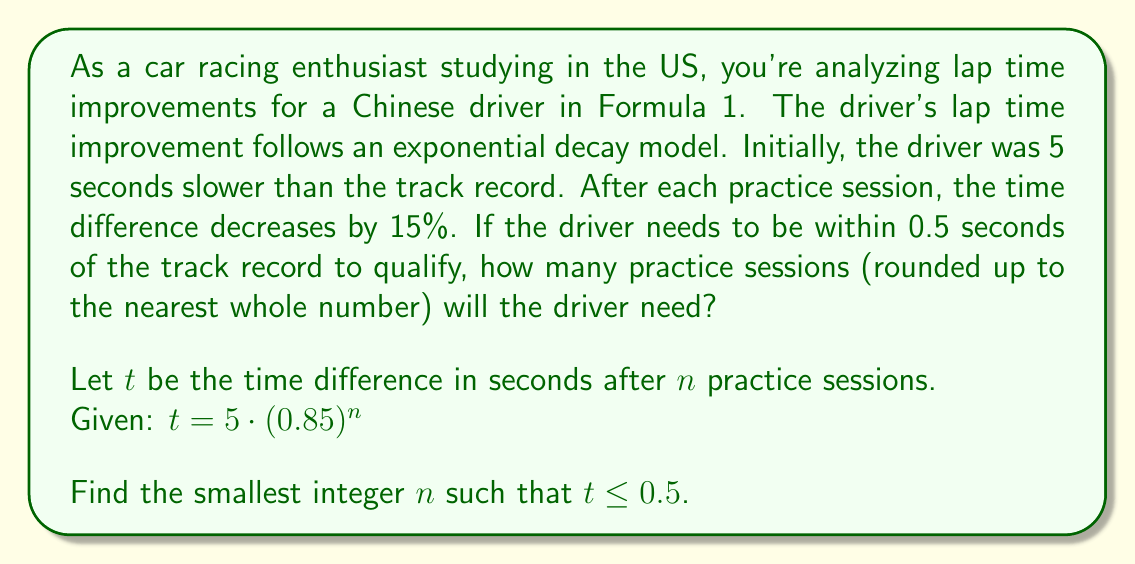What is the answer to this math problem? Let's approach this step-by-step:

1) We start with the exponential decay formula:
   $t = 5 \cdot (0.85)^n$

2) We want to find $n$ when $t \leq 0.5$. So, let's set up the inequality:
   $5 \cdot (0.85)^n \leq 0.5$

3) Divide both sides by 5:
   $(0.85)^n \leq 0.1$

4) To solve for $n$, we need to take the logarithm of both sides. Since we're dealing with a base less than 1, the inequality sign will flip when we take the log:
   $\log_{0.85}(0.85)^n \geq \log_{0.85}(0.1)$

5) Using the logarithm property $\log_a(a^x) = x$, we get:
   $n \geq \log_{0.85}(0.1)$

6) We can change this to a natural log:
   $n \geq \frac{\ln(0.1)}{\ln(0.85)}$

7) Calculating this:
   $n \geq \frac{-2.30259}{\ln(0.85)} \approx 14.43$

8) Since we need to round up to the nearest whole number of practice sessions, our final answer is 15.
Answer: The driver will need 15 practice sessions to be within 0.5 seconds of the track record. 